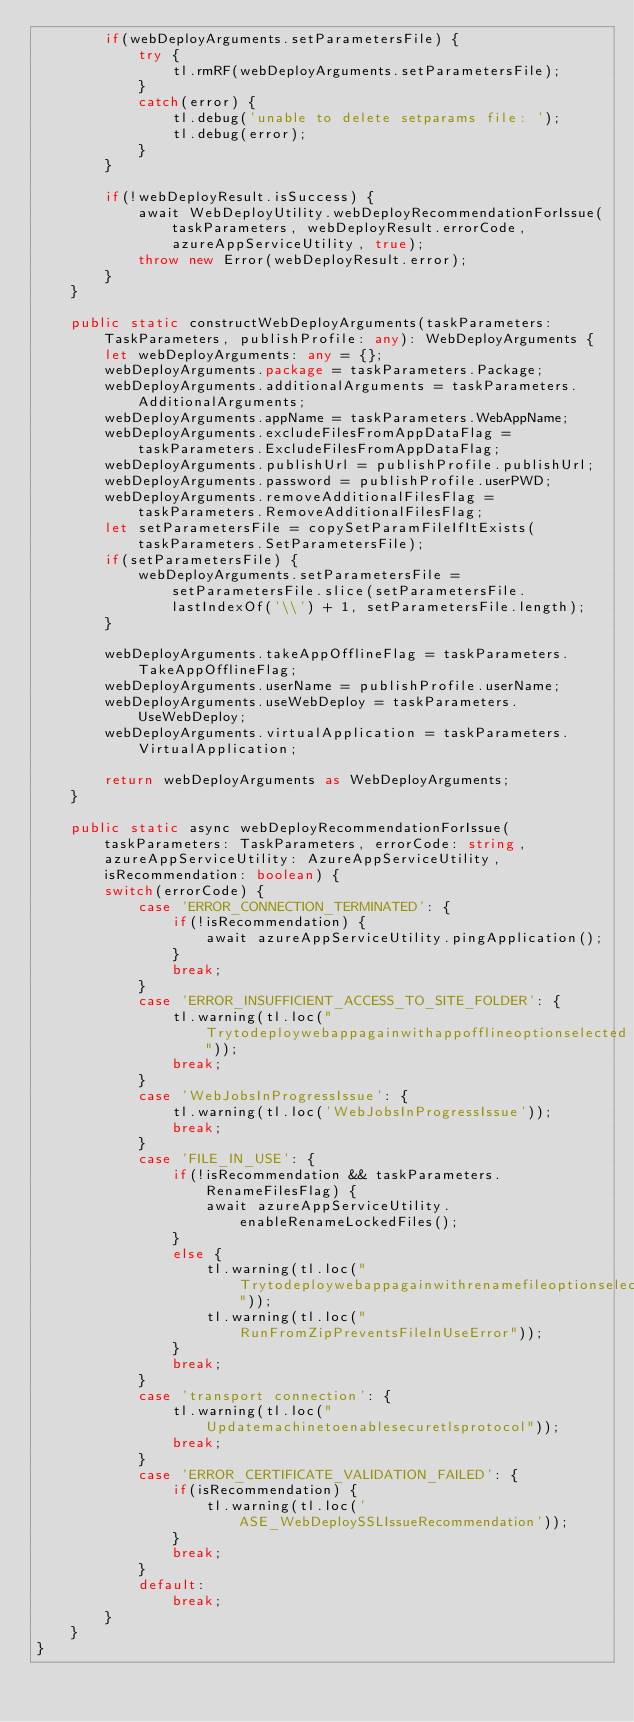<code> <loc_0><loc_0><loc_500><loc_500><_TypeScript_>        if(webDeployArguments.setParametersFile) {
            try {
                tl.rmRF(webDeployArguments.setParametersFile);
            }
            catch(error) {
                tl.debug('unable to delete setparams file: ');
                tl.debug(error);
            }
        }

        if(!webDeployResult.isSuccess) {
            await WebDeployUtility.webDeployRecommendationForIssue(taskParameters, webDeployResult.errorCode, azureAppServiceUtility, true);
            throw new Error(webDeployResult.error);
        }
    }

    public static constructWebDeployArguments(taskParameters: TaskParameters, publishProfile: any): WebDeployArguments {
        let webDeployArguments: any = {};
        webDeployArguments.package = taskParameters.Package;
        webDeployArguments.additionalArguments = taskParameters.AdditionalArguments;
        webDeployArguments.appName = taskParameters.WebAppName;
        webDeployArguments.excludeFilesFromAppDataFlag = taskParameters.ExcludeFilesFromAppDataFlag;
        webDeployArguments.publishUrl = publishProfile.publishUrl;
        webDeployArguments.password = publishProfile.userPWD;
        webDeployArguments.removeAdditionalFilesFlag = taskParameters.RemoveAdditionalFilesFlag;
        let setParametersFile = copySetParamFileIfItExists(taskParameters.SetParametersFile);
        if(setParametersFile) {
            webDeployArguments.setParametersFile = setParametersFile.slice(setParametersFile.lastIndexOf('\\') + 1, setParametersFile.length);
        }

        webDeployArguments.takeAppOfflineFlag = taskParameters.TakeAppOfflineFlag;
        webDeployArguments.userName = publishProfile.userName;
        webDeployArguments.useWebDeploy = taskParameters.UseWebDeploy;
        webDeployArguments.virtualApplication = taskParameters.VirtualApplication;

        return webDeployArguments as WebDeployArguments;
    }

    public static async webDeployRecommendationForIssue(taskParameters: TaskParameters, errorCode: string, azureAppServiceUtility: AzureAppServiceUtility, isRecommendation: boolean) {
        switch(errorCode) {
            case 'ERROR_CONNECTION_TERMINATED': {
                if(!isRecommendation) {
                    await azureAppServiceUtility.pingApplication();
                }
                break;
            }
            case 'ERROR_INSUFFICIENT_ACCESS_TO_SITE_FOLDER': {
                tl.warning(tl.loc("Trytodeploywebappagainwithappofflineoptionselected"));
                break;
            }
            case 'WebJobsInProgressIssue': {
                tl.warning(tl.loc('WebJobsInProgressIssue'));
                break;
            }
            case 'FILE_IN_USE': {
                if(!isRecommendation && taskParameters.RenameFilesFlag) {
                    await azureAppServiceUtility.enableRenameLockedFiles();
                }
                else {
                    tl.warning(tl.loc("Trytodeploywebappagainwithrenamefileoptionselected"));
                    tl.warning(tl.loc("RunFromZipPreventsFileInUseError"));
                }
                break;
            }
            case 'transport connection': {
                tl.warning(tl.loc("Updatemachinetoenablesecuretlsprotocol"));
                break;
            }
            case 'ERROR_CERTIFICATE_VALIDATION_FAILED': {
                if(isRecommendation) {
                    tl.warning(tl.loc('ASE_WebDeploySSLIssueRecommendation'));
                }
                break;
            }
            default:
                break;
        }
    }
}</code> 